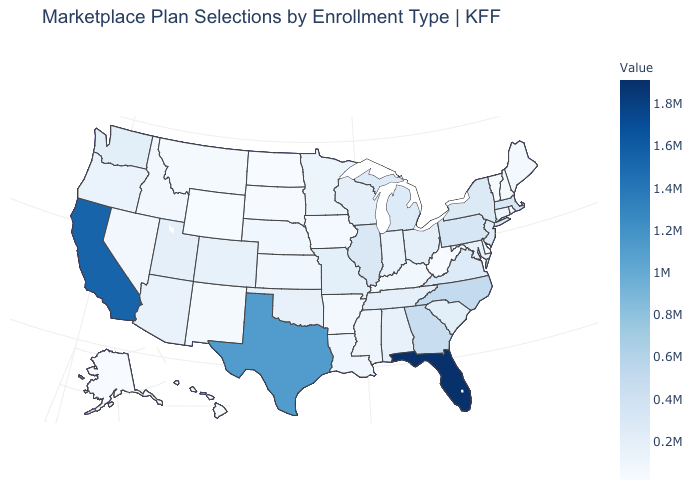Does the map have missing data?
Keep it brief. No. Does Arkansas have the lowest value in the USA?
Be succinct. No. Which states have the lowest value in the MidWest?
Concise answer only. North Dakota. Which states hav the highest value in the Northeast?
Be succinct. Pennsylvania. Does Delaware have the lowest value in the USA?
Write a very short answer. No. 